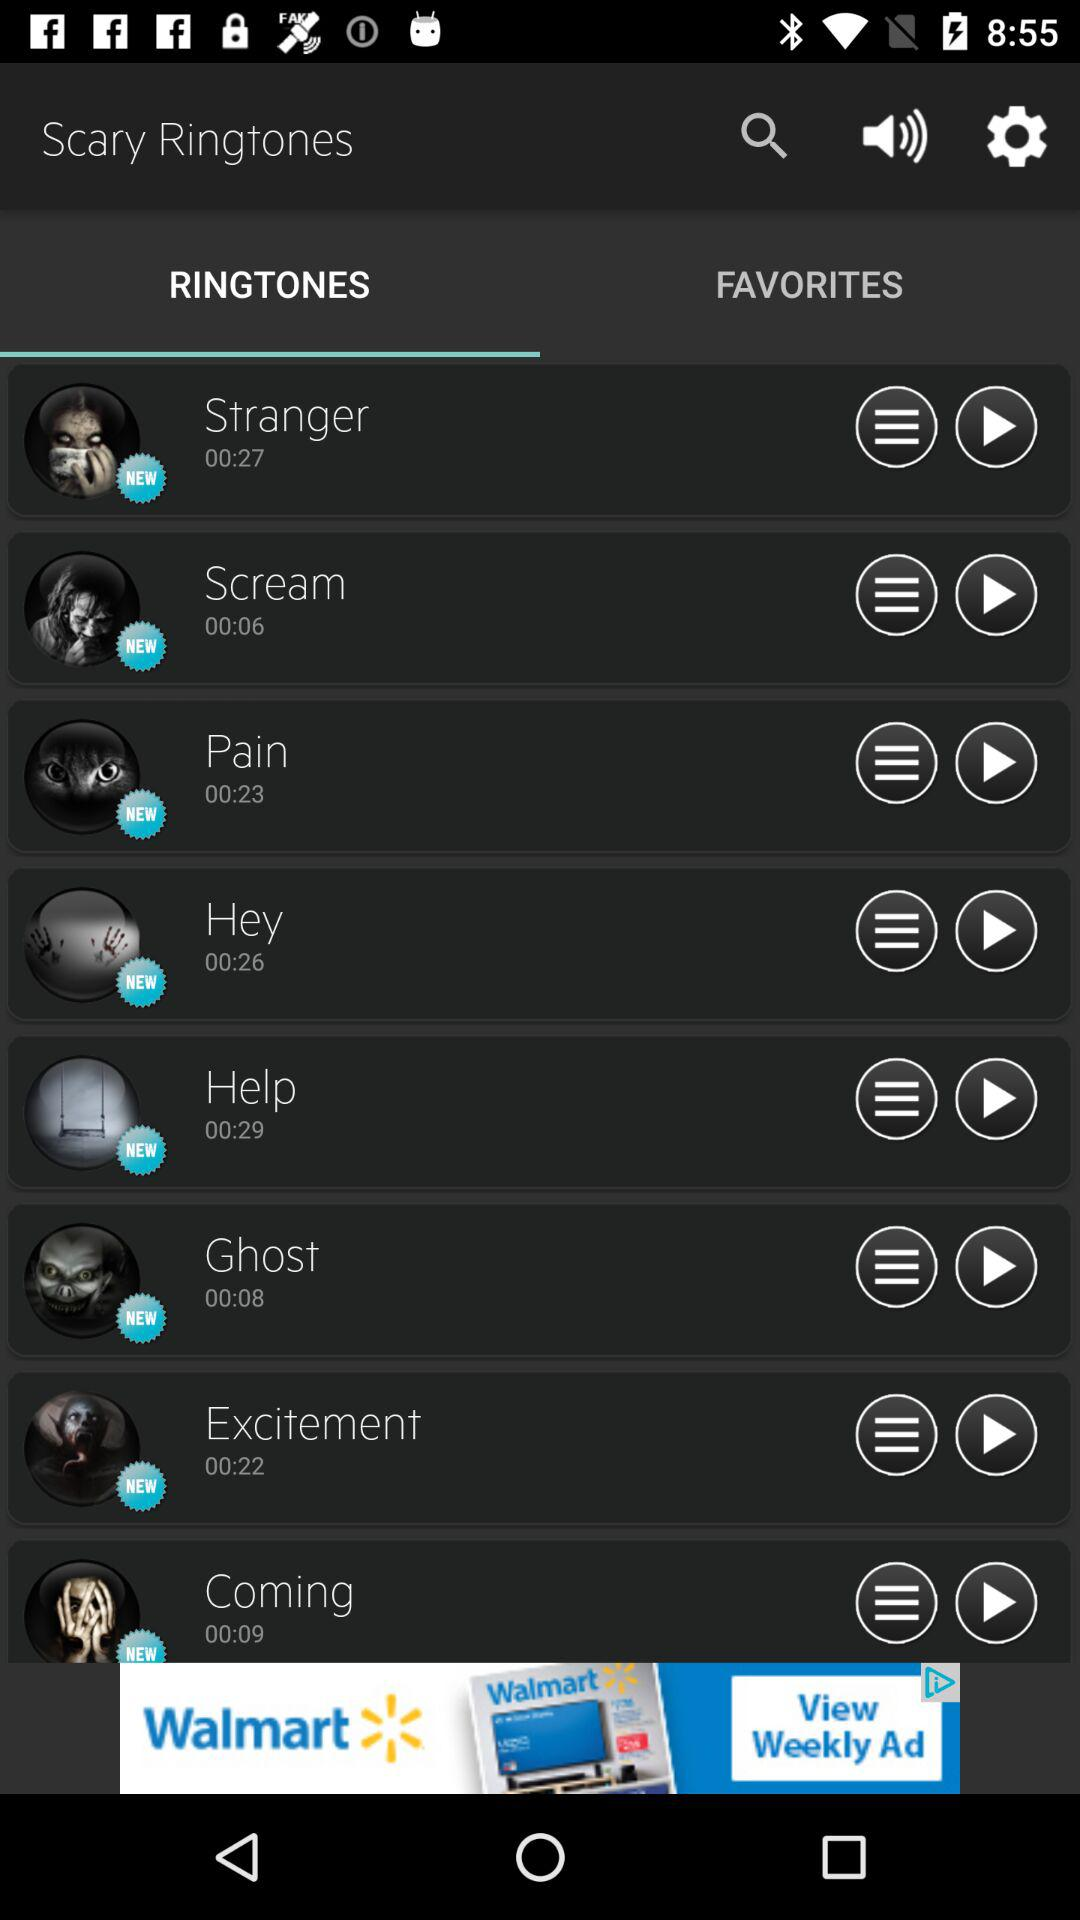What is the duration of the ringtone "Stranger"? The duration is 27 seconds. 